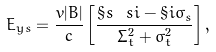<formula> <loc_0><loc_0><loc_500><loc_500>E _ { y s } = \frac { v | B | } { c } \left [ \frac { \S s \ s i - \S i \sigma _ { s } } { \Sigma _ { t } ^ { 2 } + \sigma _ { t } ^ { 2 } } \right ] ,</formula> 